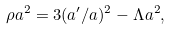Convert formula to latex. <formula><loc_0><loc_0><loc_500><loc_500>\rho a ^ { 2 } = 3 ( a ^ { \prime } / a ) ^ { 2 } - \Lambda a ^ { 2 } ,</formula> 